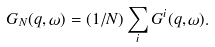Convert formula to latex. <formula><loc_0><loc_0><loc_500><loc_500>G _ { N } ( q , \omega ) = ( 1 / N ) \sum _ { i } G ^ { i } ( q , \omega ) .</formula> 